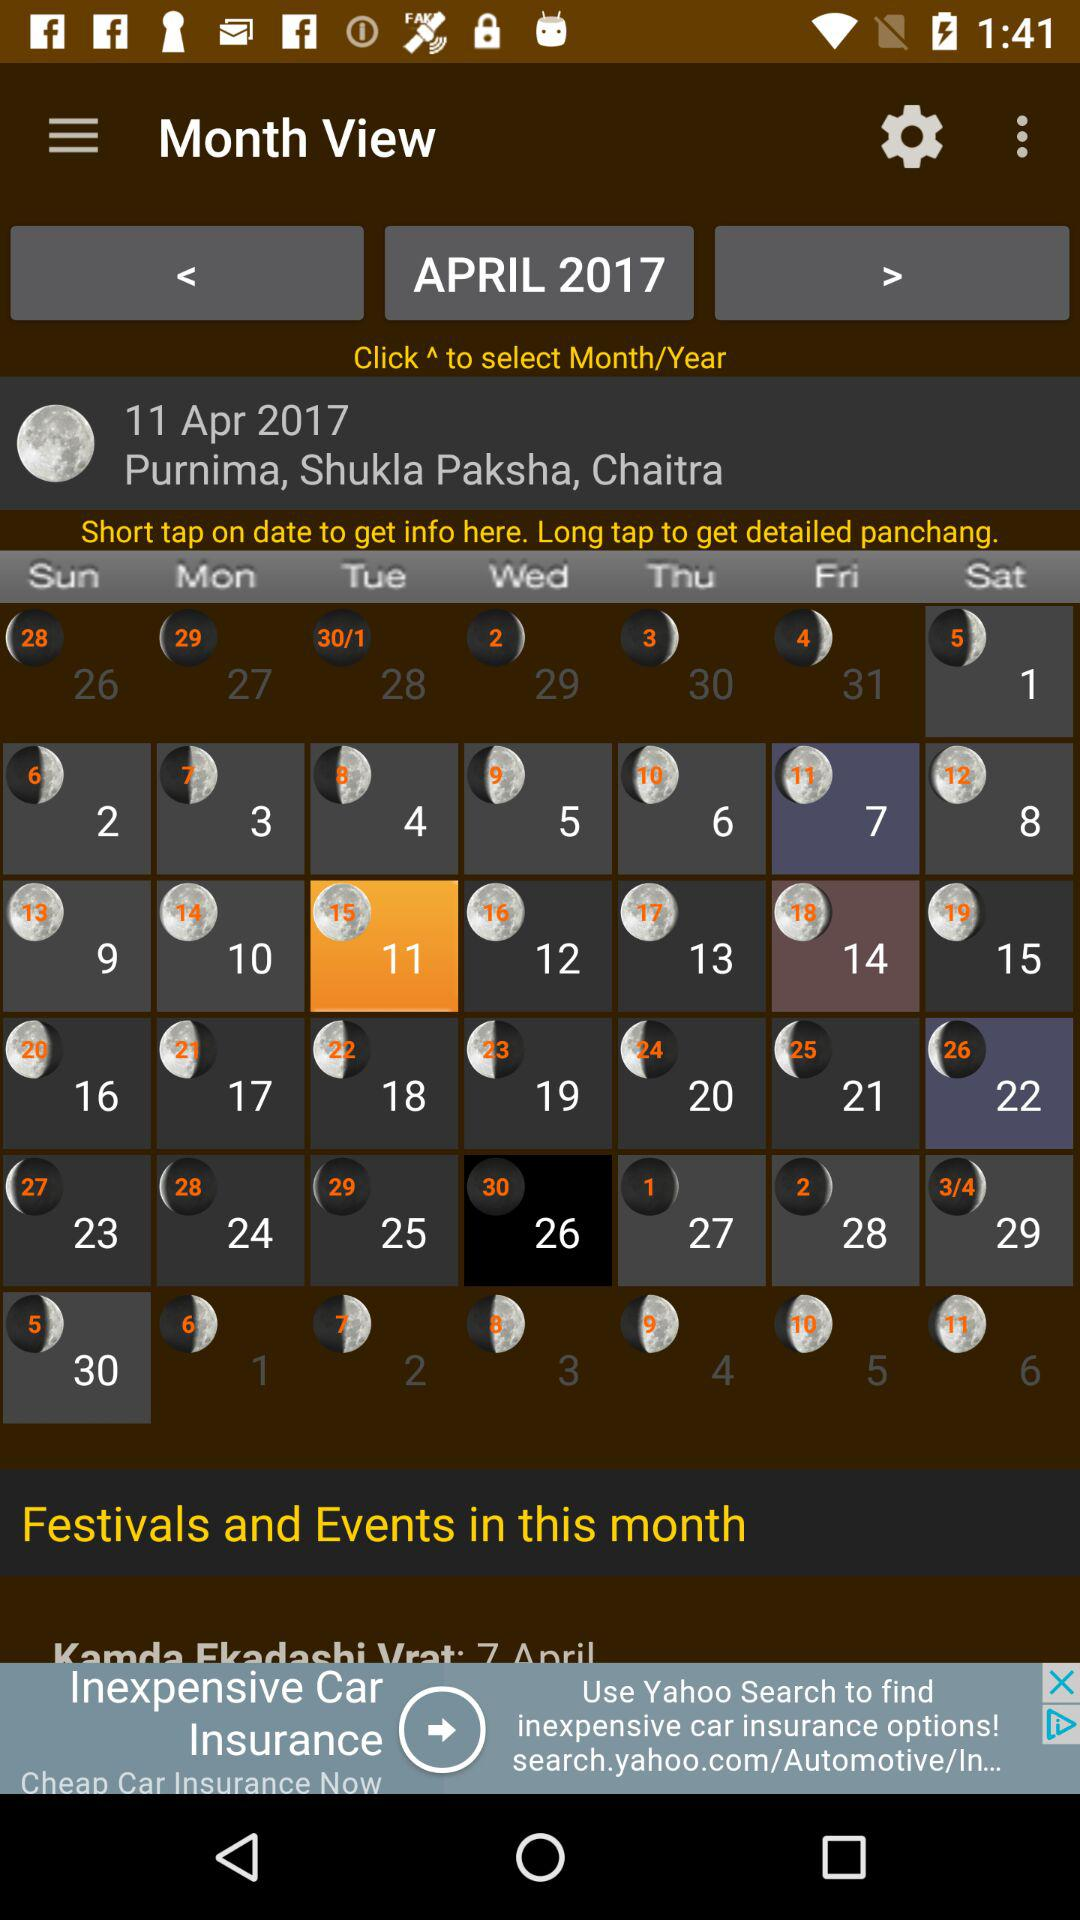Which month and year are shown? The shown month and year are April and 2017, respectively. 